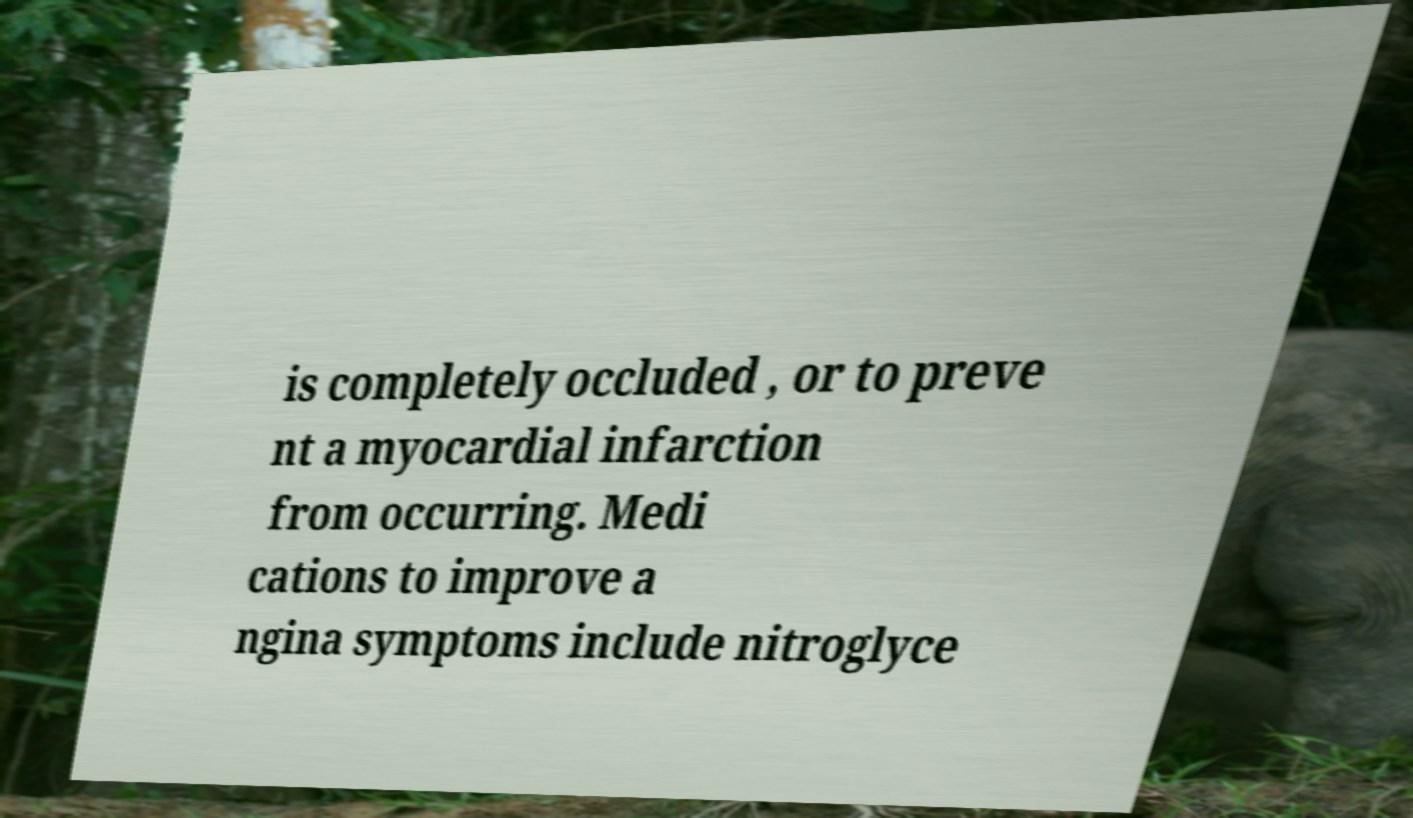Please read and relay the text visible in this image. What does it say? is completely occluded , or to preve nt a myocardial infarction from occurring. Medi cations to improve a ngina symptoms include nitroglyce 